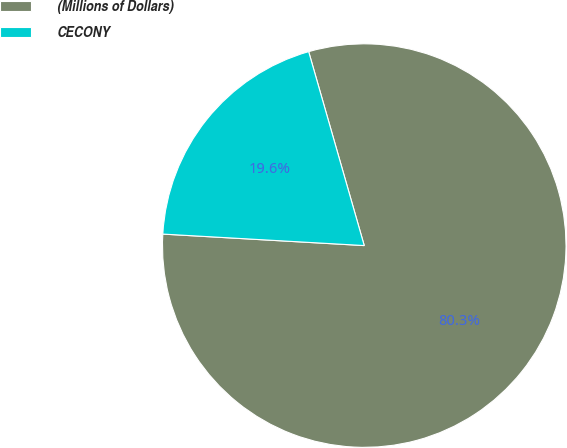Convert chart. <chart><loc_0><loc_0><loc_500><loc_500><pie_chart><fcel>(Millions of Dollars)<fcel>CECONY<nl><fcel>80.35%<fcel>19.65%<nl></chart> 